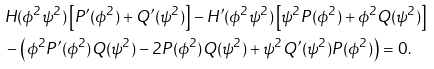Convert formula to latex. <formula><loc_0><loc_0><loc_500><loc_500>& H ( \phi ^ { 2 } \psi ^ { 2 } ) \left [ P ^ { \prime } ( \phi ^ { 2 } ) + Q ^ { \prime } ( \psi ^ { 2 } ) \right ] - H ^ { \prime } ( \phi ^ { 2 } \psi ^ { 2 } ) \left [ \psi ^ { 2 } P ( \phi ^ { 2 } ) + \phi ^ { 2 } Q ( \psi ^ { 2 } ) \right ] \\ & - \left ( \phi ^ { 2 } P ^ { \prime } ( \phi ^ { 2 } ) Q ( \psi ^ { 2 } ) - 2 P ( \phi ^ { 2 } ) Q ( \psi ^ { 2 } ) + \psi ^ { 2 } Q ^ { \prime } ( \psi ^ { 2 } ) P ( \phi ^ { 2 } ) \right ) = 0 .</formula> 